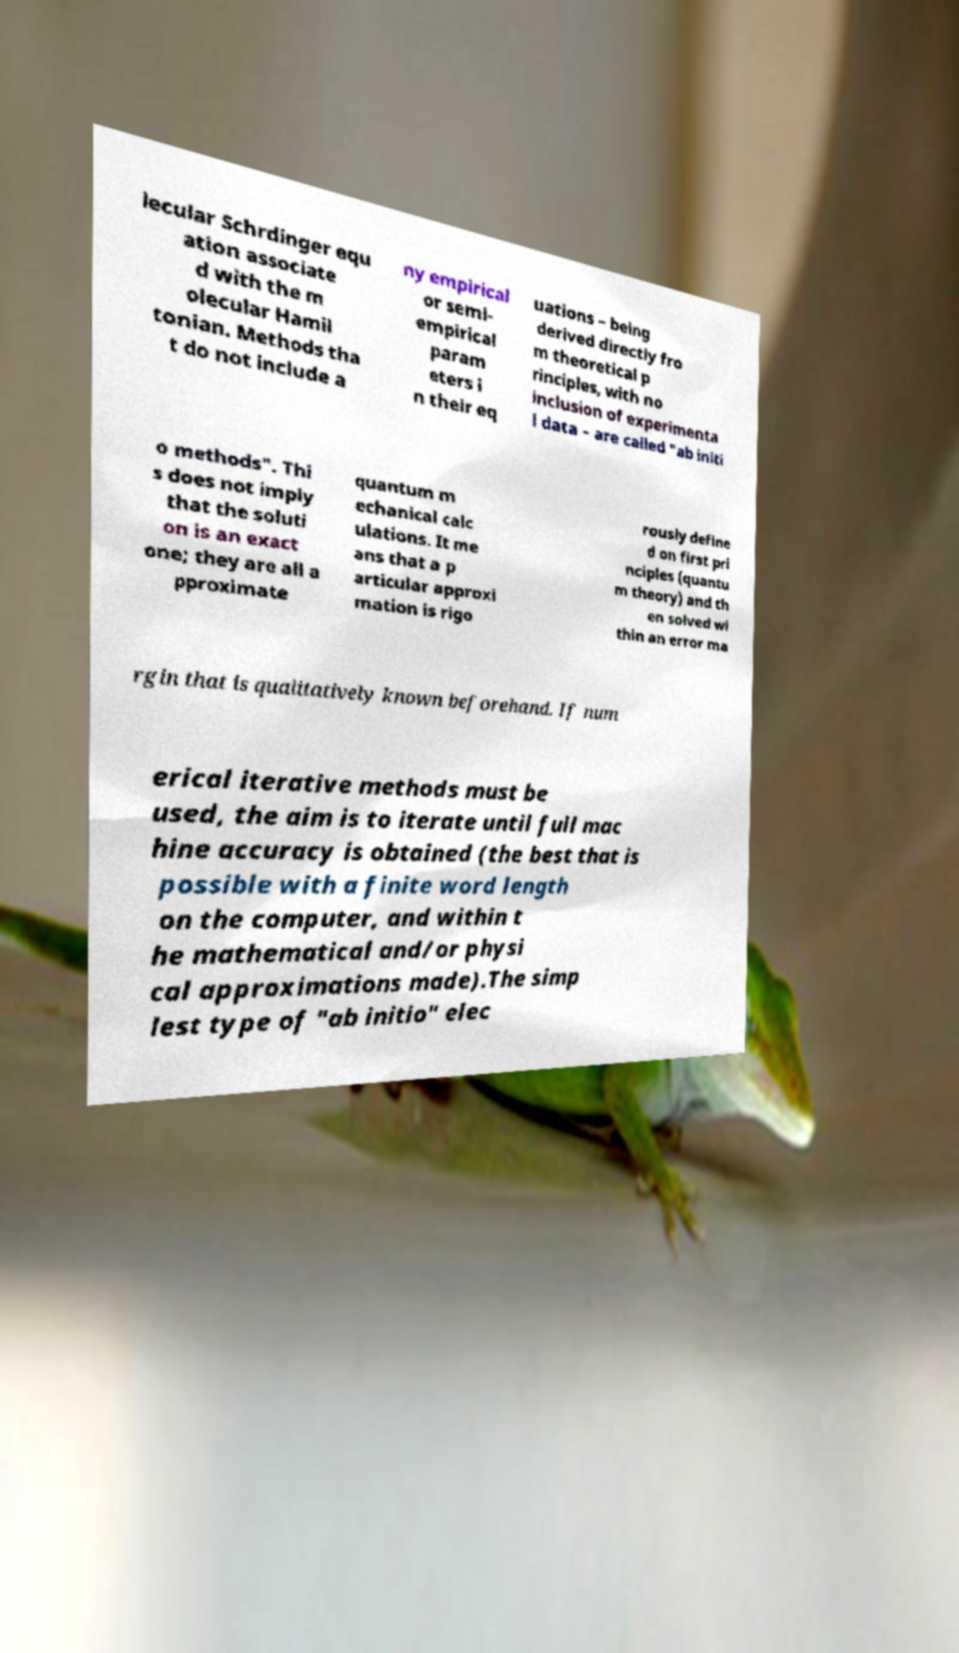Can you read and provide the text displayed in the image?This photo seems to have some interesting text. Can you extract and type it out for me? lecular Schrdinger equ ation associate d with the m olecular Hamil tonian. Methods tha t do not include a ny empirical or semi- empirical param eters i n their eq uations – being derived directly fro m theoretical p rinciples, with no inclusion of experimenta l data – are called "ab initi o methods". Thi s does not imply that the soluti on is an exact one; they are all a pproximate quantum m echanical calc ulations. It me ans that a p articular approxi mation is rigo rously define d on first pri nciples (quantu m theory) and th en solved wi thin an error ma rgin that is qualitatively known beforehand. If num erical iterative methods must be used, the aim is to iterate until full mac hine accuracy is obtained (the best that is possible with a finite word length on the computer, and within t he mathematical and/or physi cal approximations made).The simp lest type of "ab initio" elec 